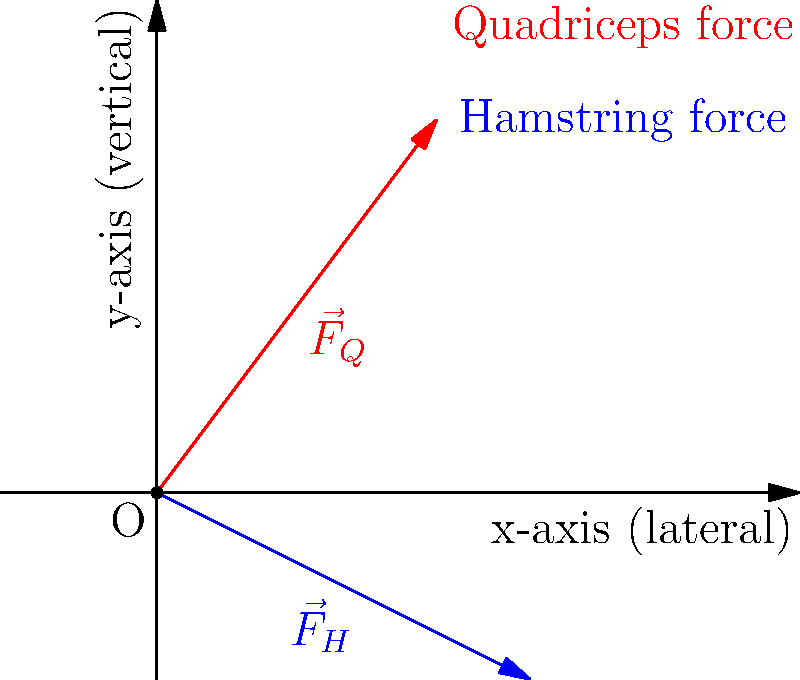During a popular dance move called the "Moonwalk," a dancer's leg experiences forces from the quadriceps and hamstrings. The quadriceps force ($\vec{F}_Q$) has components of 3 units laterally and 4 units vertically, while the hamstring force ($\vec{F}_H$) has components of 4 units laterally and -2 units vertically. What is the magnitude of the resultant force vector acting on the dancer's leg? To find the magnitude of the resultant force vector, we need to follow these steps:

1. Identify the components of each force vector:
   $\vec{F}_Q = (3, 4)$
   $\vec{F}_H = (4, -2)$

2. Calculate the sum of the force vectors:
   $\vec{F}_R = \vec{F}_Q + \vec{F}_H$
   $\vec{F}_R = (3 + 4, 4 + (-2))$
   $\vec{F}_R = (7, 2)$

3. Use the Pythagorean theorem to calculate the magnitude of the resultant force:
   $|\vec{F}_R| = \sqrt{(7)^2 + (2)^2}$
   $|\vec{F}_R| = \sqrt{49 + 4}$
   $|\vec{F}_R| = \sqrt{53}$

4. Simplify the square root:
   $|\vec{F}_R| \approx 7.28$ units

The magnitude of the resultant force vector is approximately 7.28 units.
Answer: $\sqrt{53}$ units (or approximately 7.28 units) 